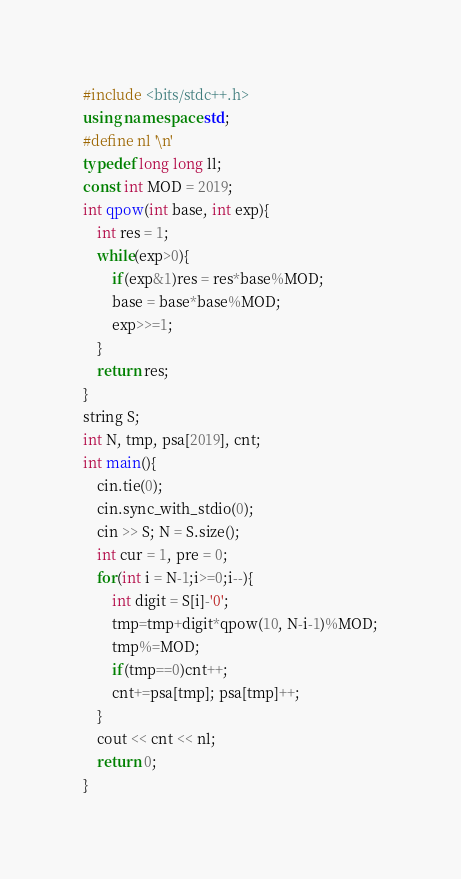<code> <loc_0><loc_0><loc_500><loc_500><_C++_>#include <bits/stdc++.h>
using namespace std;
#define nl '\n'
typedef long long ll;
const int MOD = 2019;
int qpow(int base, int exp){
	int res = 1;
	while(exp>0){
		if(exp&1)res = res*base%MOD;
		base = base*base%MOD;
		exp>>=1;
	}
	return res;
}
string S;
int N, tmp, psa[2019], cnt;
int main(){
	cin.tie(0);
	cin.sync_with_stdio(0);
	cin >> S; N = S.size();
	int cur = 1, pre = 0;
	for(int i = N-1;i>=0;i--){
		int digit = S[i]-'0';
		tmp=tmp+digit*qpow(10, N-i-1)%MOD;
		tmp%=MOD;
		if(tmp==0)cnt++;
		cnt+=psa[tmp]; psa[tmp]++;
	}
	cout << cnt << nl;
	return 0;
}</code> 